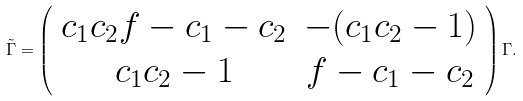<formula> <loc_0><loc_0><loc_500><loc_500>\tilde { \Gamma } = \left ( \begin{array} { c c } c _ { 1 } c _ { 2 } f - c _ { 1 } - c _ { 2 } & - ( c _ { 1 } c _ { 2 } - 1 ) \\ c _ { 1 } c _ { 2 } - 1 & f - c _ { 1 } - c _ { 2 } \end{array} \right ) \Gamma .</formula> 